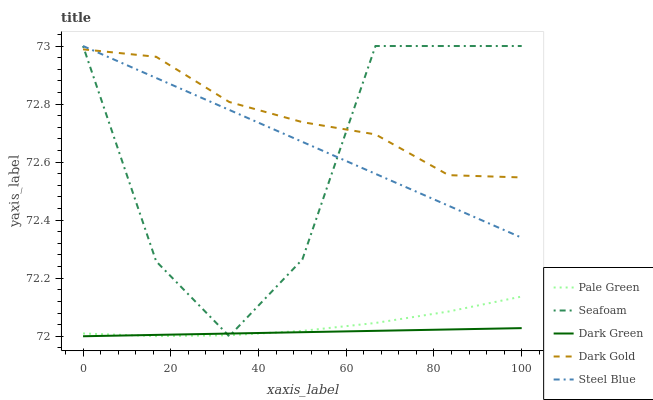Does Pale Green have the minimum area under the curve?
Answer yes or no. No. Does Pale Green have the maximum area under the curve?
Answer yes or no. No. Is Pale Green the smoothest?
Answer yes or no. No. Is Pale Green the roughest?
Answer yes or no. No. Does Pale Green have the lowest value?
Answer yes or no. No. Does Pale Green have the highest value?
Answer yes or no. No. Is Dark Green less than Steel Blue?
Answer yes or no. Yes. Is Dark Gold greater than Pale Green?
Answer yes or no. Yes. Does Dark Green intersect Steel Blue?
Answer yes or no. No. 